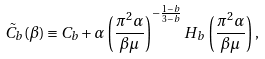Convert formula to latex. <formula><loc_0><loc_0><loc_500><loc_500>\tilde { C } _ { b } ( \beta ) \equiv C _ { b } + \alpha \left ( \frac { \pi ^ { 2 } \alpha } { \beta \mu } \right ) ^ { - \frac { 1 - b } { 3 - b } } H _ { b } \, \left ( \frac { \pi ^ { 2 } \alpha } { \beta \mu } \right ) ,</formula> 